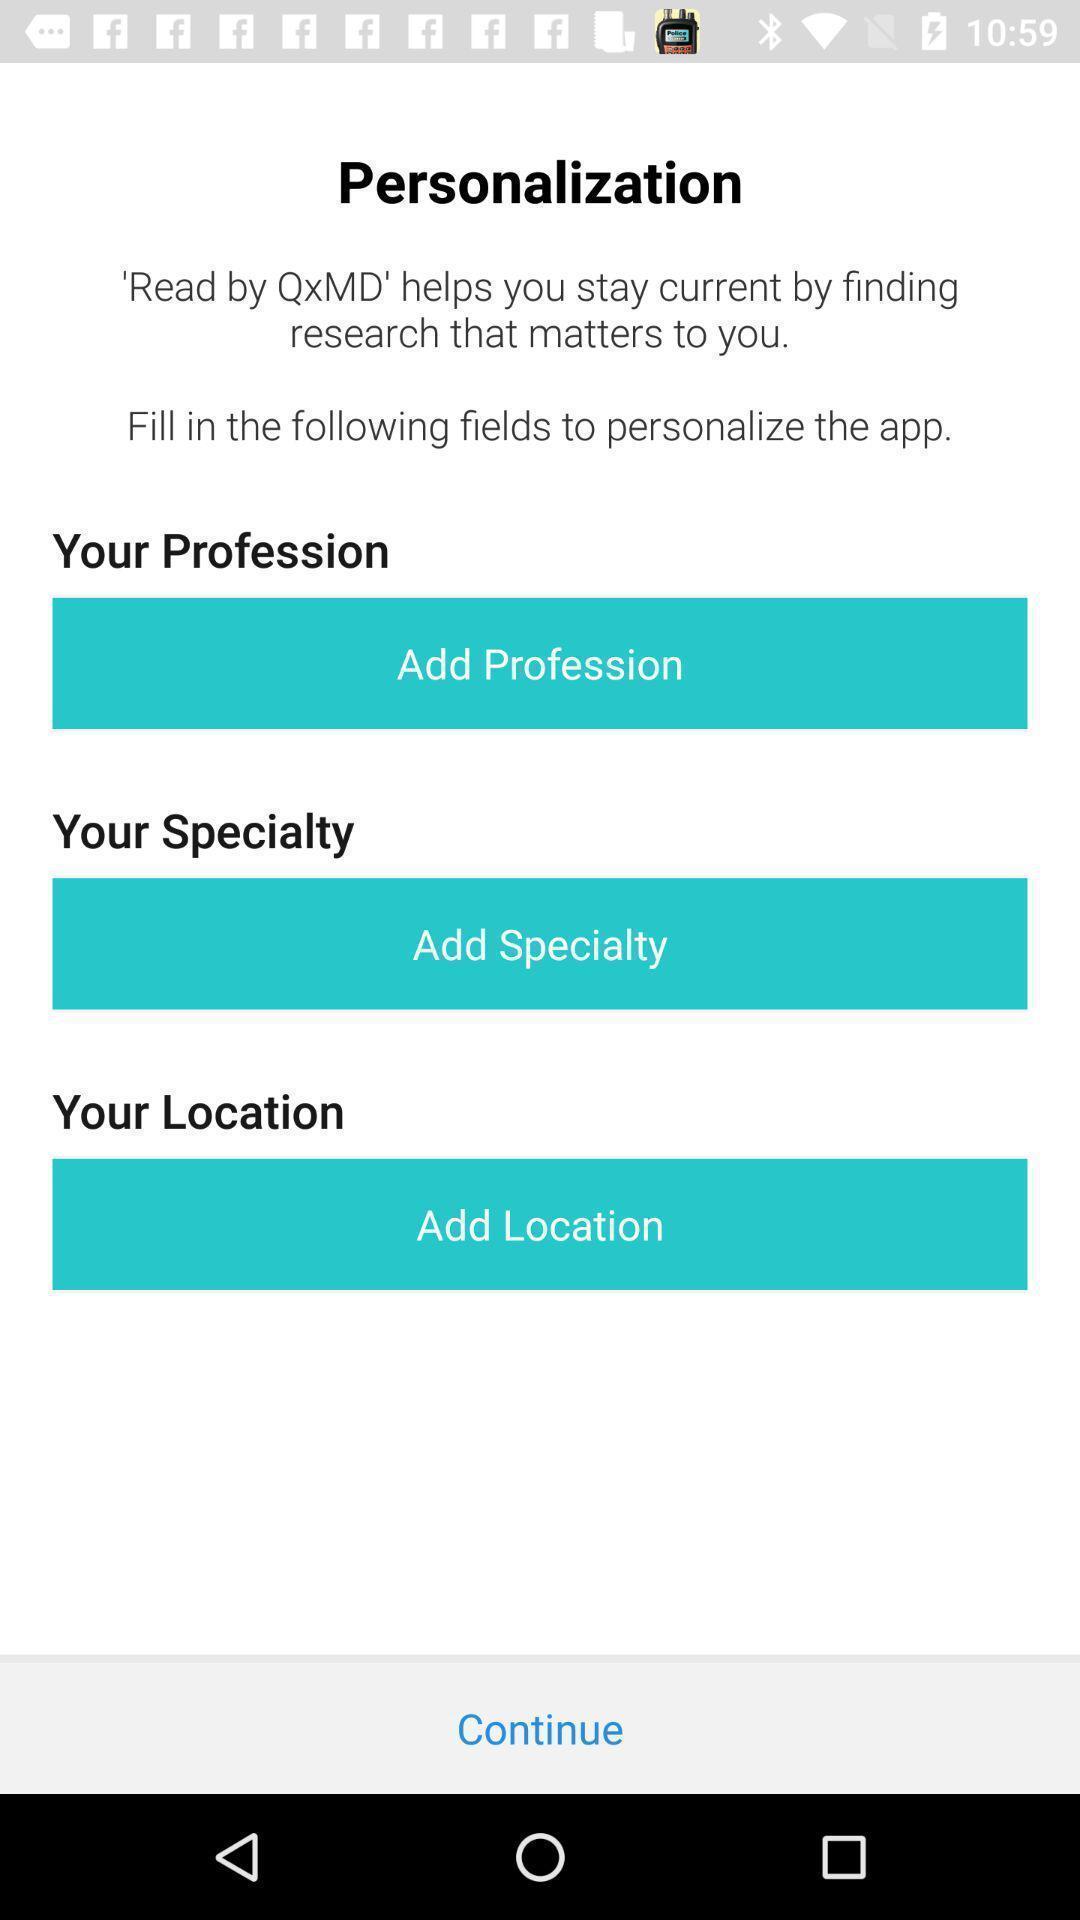Describe this image in words. Screen showing personalization. 